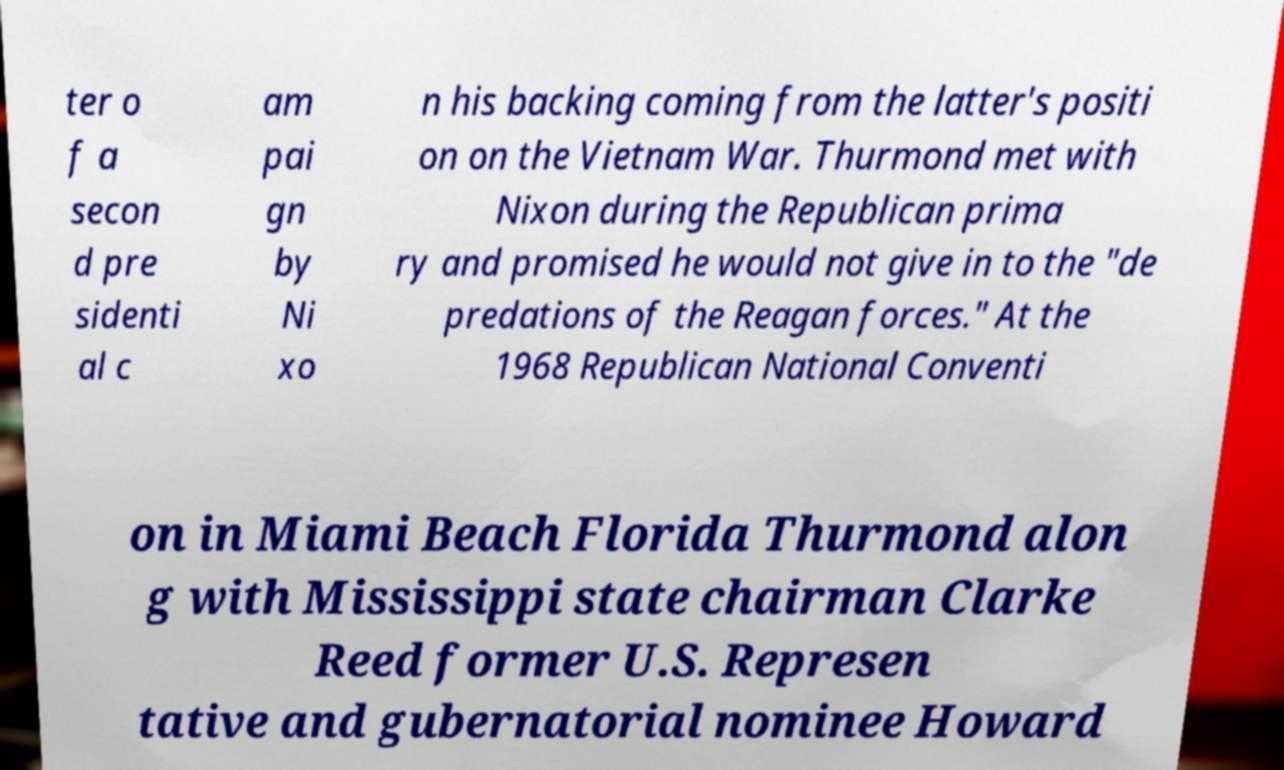Please identify and transcribe the text found in this image. ter o f a secon d pre sidenti al c am pai gn by Ni xo n his backing coming from the latter's positi on on the Vietnam War. Thurmond met with Nixon during the Republican prima ry and promised he would not give in to the "de predations of the Reagan forces." At the 1968 Republican National Conventi on in Miami Beach Florida Thurmond alon g with Mississippi state chairman Clarke Reed former U.S. Represen tative and gubernatorial nominee Howard 